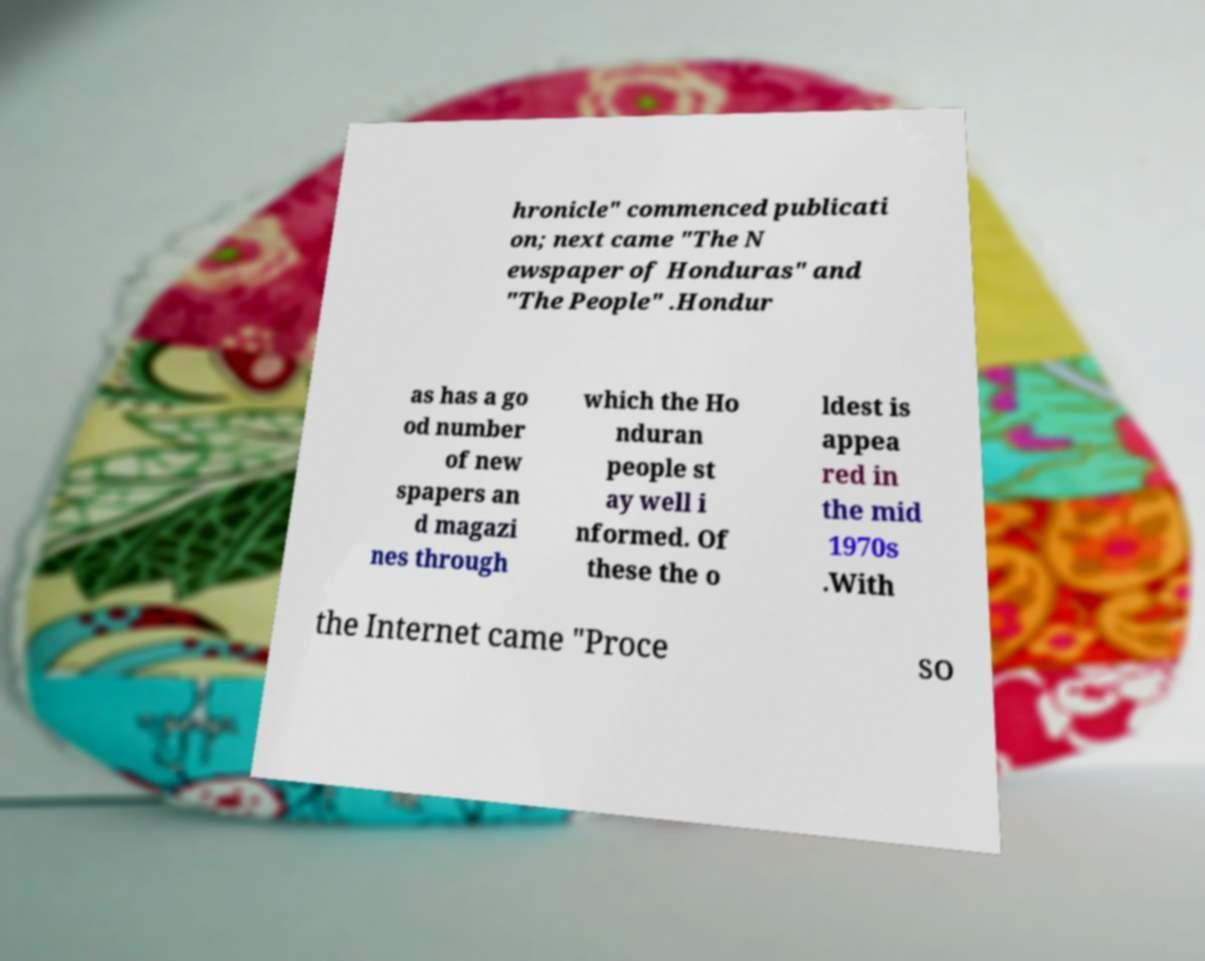Can you accurately transcribe the text from the provided image for me? hronicle" commenced publicati on; next came "The N ewspaper of Honduras" and "The People" .Hondur as has a go od number of new spapers an d magazi nes through which the Ho nduran people st ay well i nformed. Of these the o ldest is appea red in the mid 1970s .With the Internet came "Proce so 